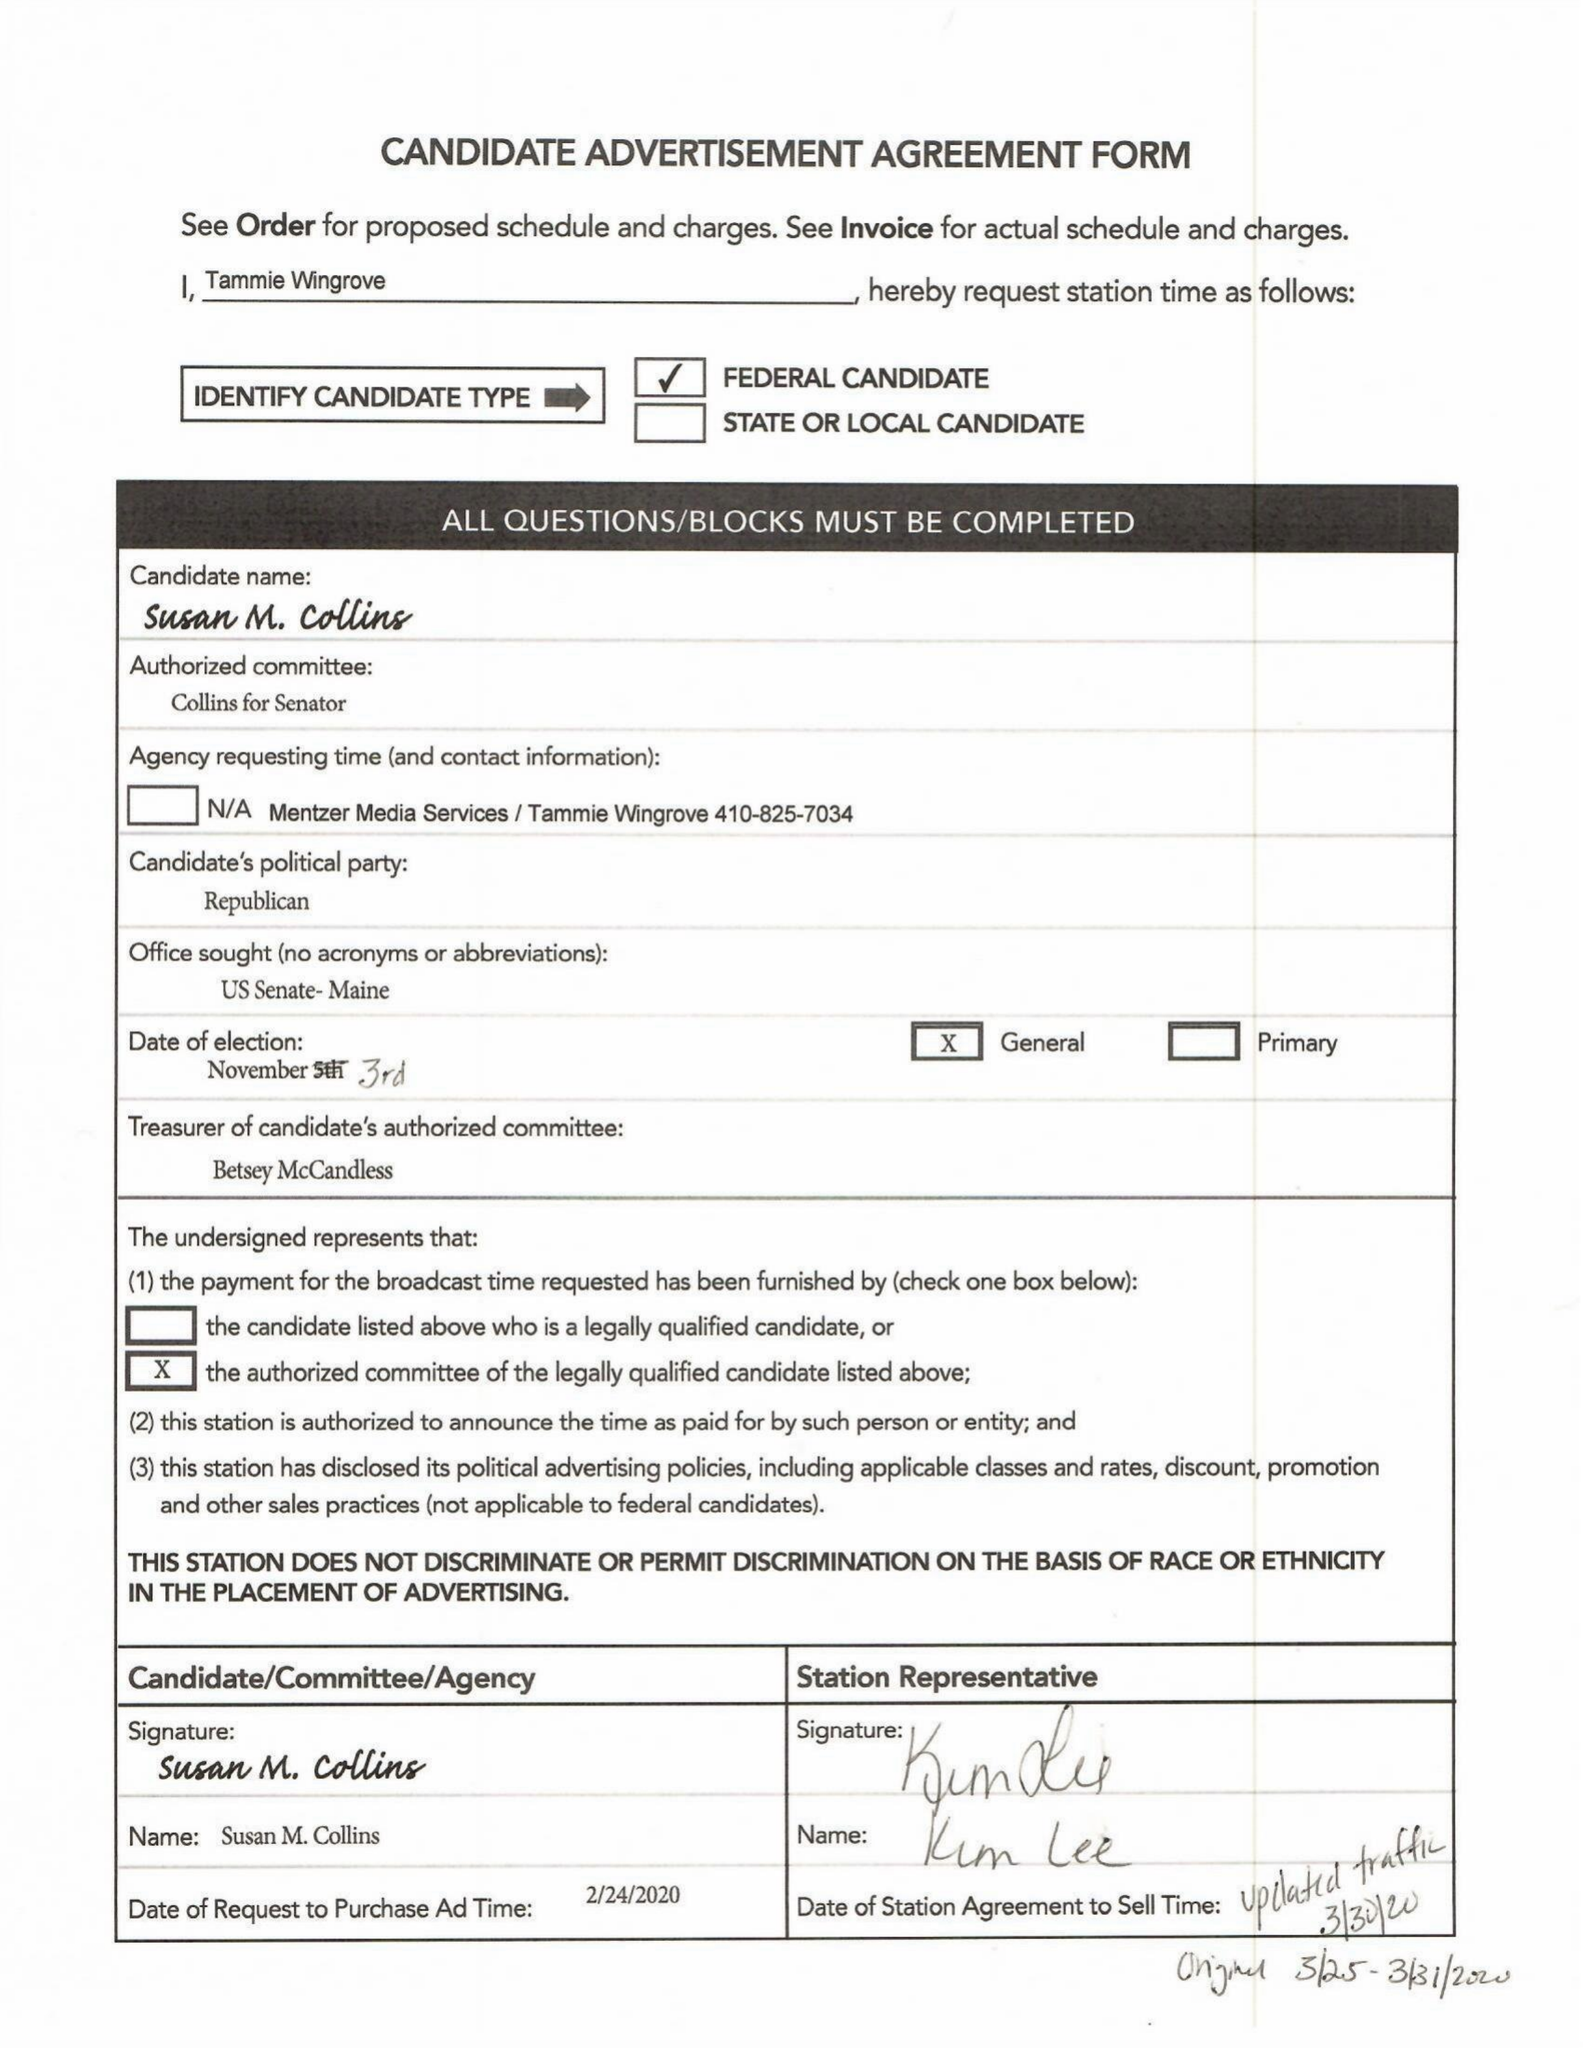What is the value for the gross_amount?
Answer the question using a single word or phrase. None 